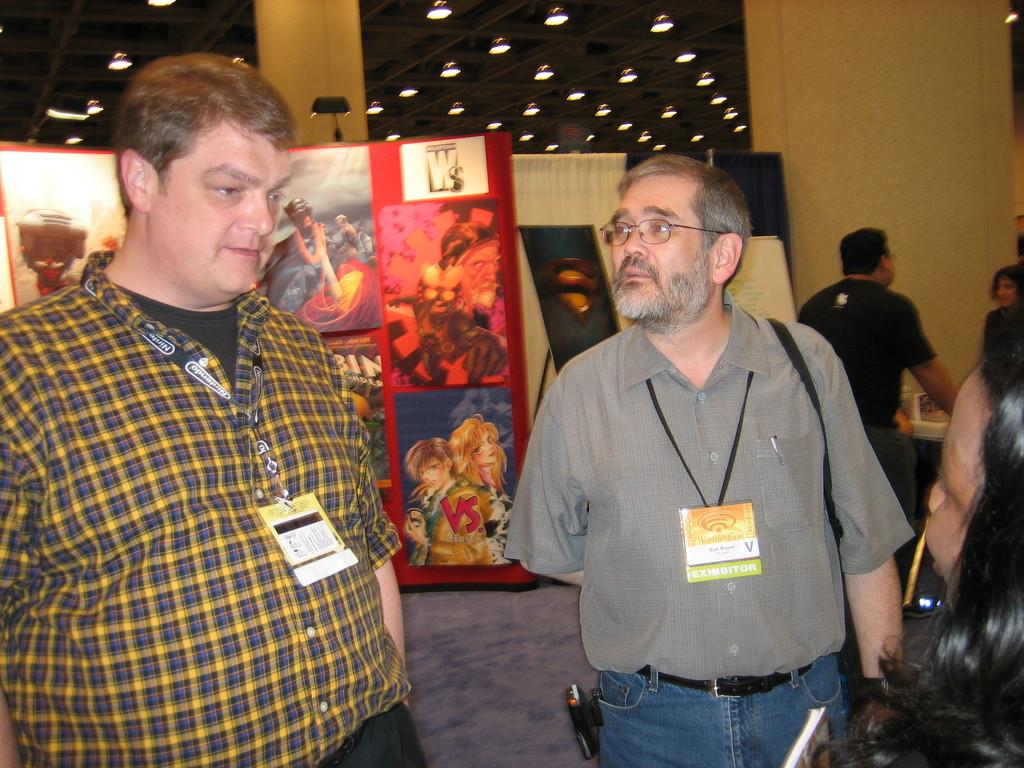Who or what is present in the image? There are people in the image. What can be observed about some of the people in the image? Some of the people are wearing tags. What can be seen in the background of the image? There is a board with images in the background. What type of lighting is present in the image? There are lights on the ceiling. How much land does the business own in the image? There is no mention of a business or land ownership in the image. 